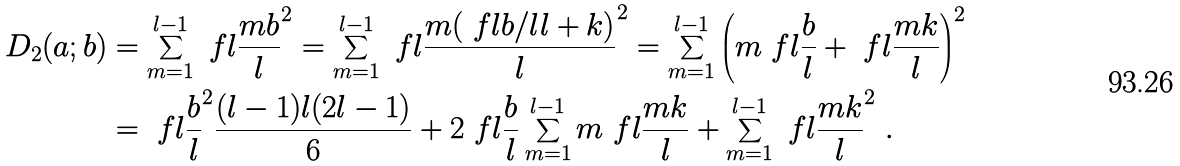<formula> <loc_0><loc_0><loc_500><loc_500>D _ { 2 } ( a ; b ) & = \sum _ { m = 1 } ^ { l - 1 } \ f l { \frac { m b } { l } } ^ { 2 } = \sum _ { m = 1 } ^ { l - 1 } \ f l { \frac { m ( \ f l { b / l } l + k ) } { l } } ^ { 2 } = \sum _ { m = 1 } ^ { l - 1 } \left ( m \ f l { \frac { b } { l } } + \ f l { \frac { m k } { l } } \right ) ^ { 2 } \\ & = \ f l { \frac { b } { l } } ^ { 2 } \frac { ( l - 1 ) l ( 2 l - 1 ) } { 6 } + 2 \ f l { \frac { b } { l } } \sum _ { m = 1 } ^ { l - 1 } m \ f l { \frac { m k } { l } } + \sum _ { m = 1 } ^ { l - 1 } \ f l { \frac { m k } { l } } ^ { 2 } \ .</formula> 